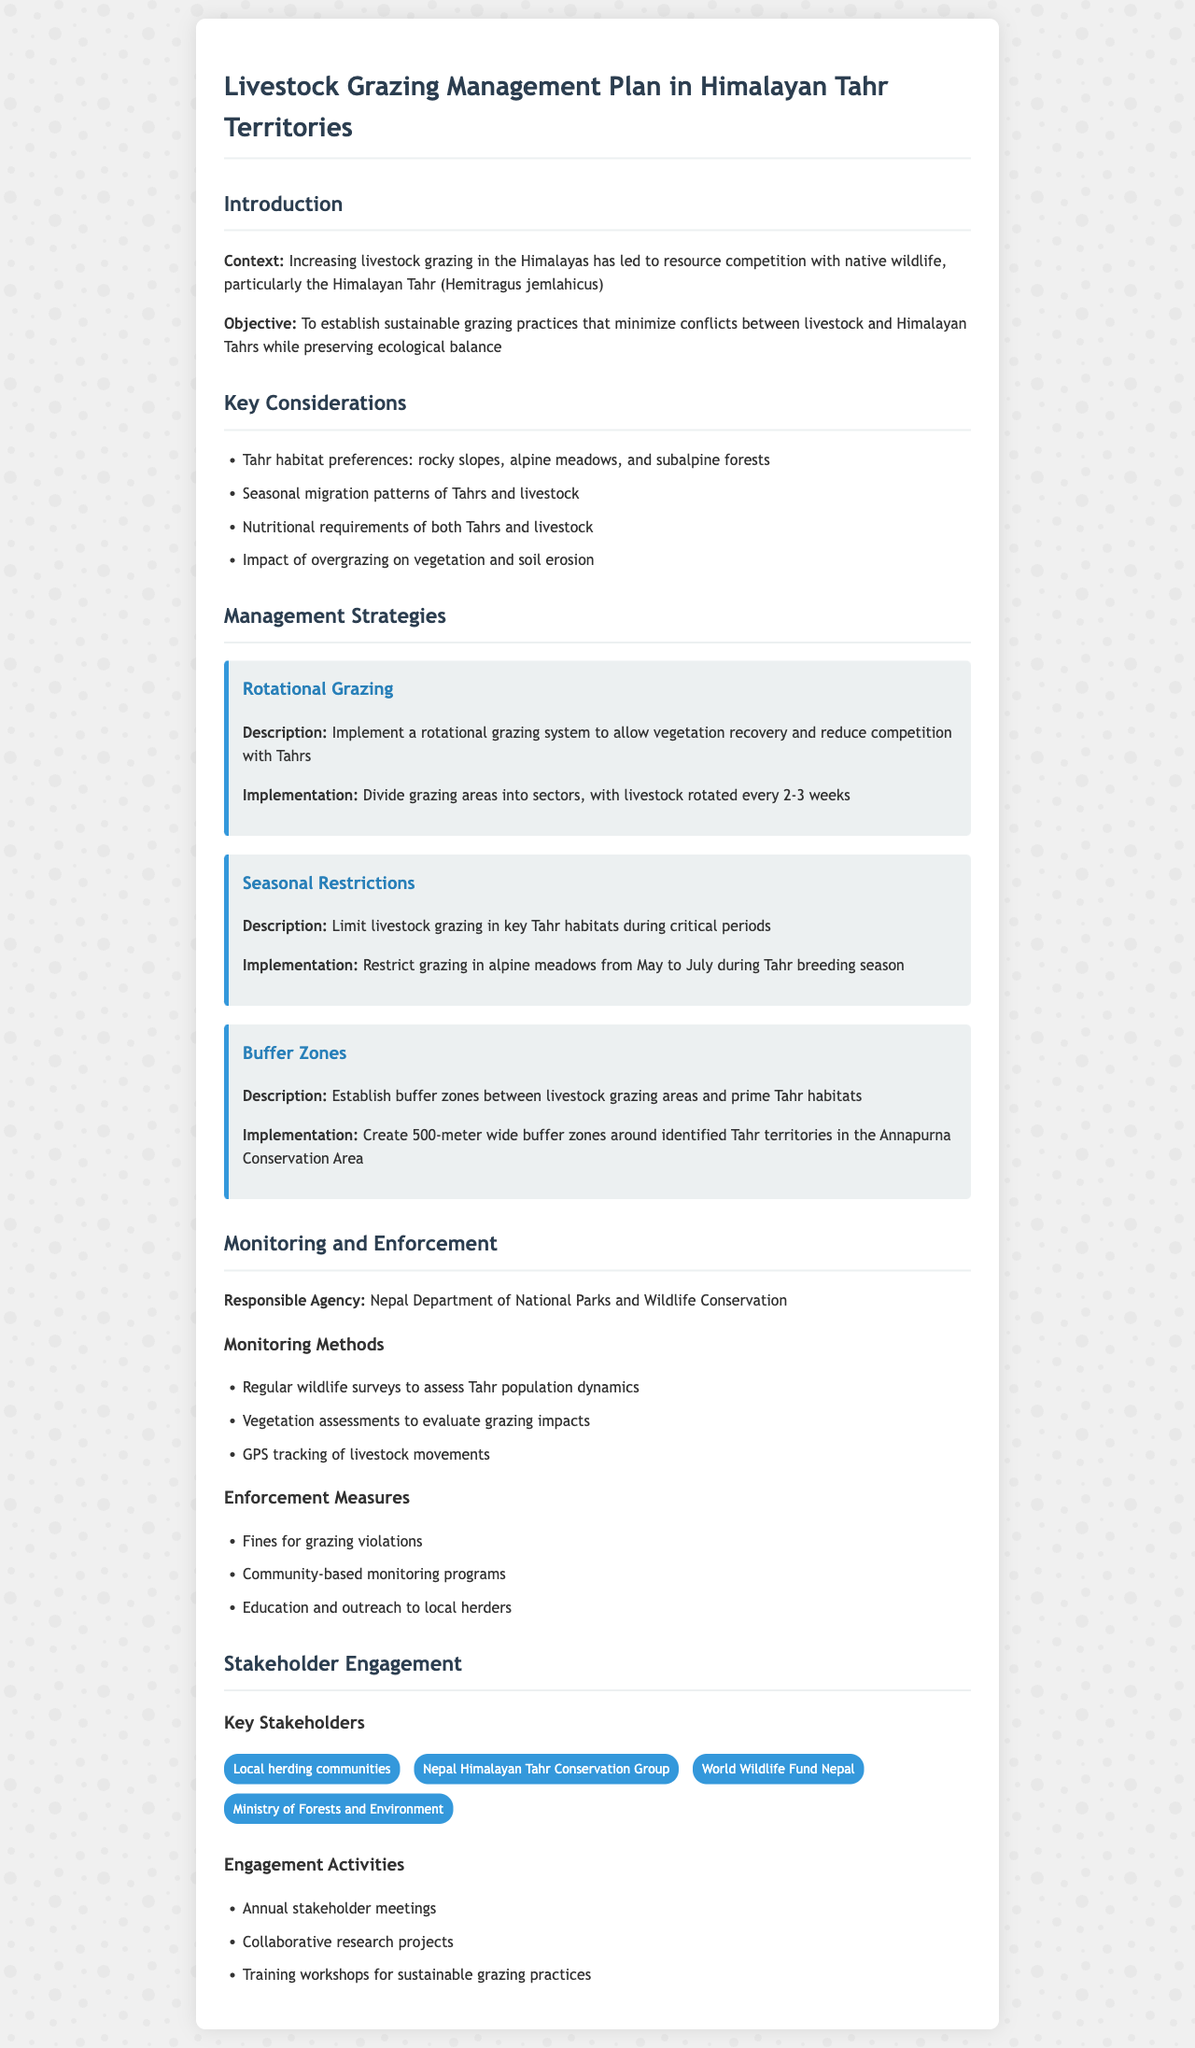What is the main objective of the grazing management plan? The objective is to establish sustainable grazing practices that minimize conflicts between livestock and Himalayan Tahrs while preserving ecological balance.
Answer: sustainable grazing practices What strategy involves dividing grazing areas into sectors? The strategy that implements a rotational grazing system requires the division of grazing areas into sectors for livestock rotation.
Answer: Rotational Grazing During which months are livestock grazing restrictions applied in key Tahr habitats? The grazing restrictions are applied from May to July during the critical Tahr breeding season.
Answer: May to July Which agency is responsible for monitoring the grazing management plan? The agency responsible for monitoring is the Nepal Department of National Parks and Wildlife Conservation.
Answer: Nepal Department of National Parks and Wildlife Conservation What is the width of the established buffer zones around Tahr territories? The buffer zones established around identified Tahr territories are 500 meters wide.
Answer: 500-meter What is one method used for monitoring livestock movements? GPS tracking is one method used to monitor livestock movements.
Answer: GPS tracking What type of communities are key stakeholders in this plan? Local herding communities are identified as key stakeholders in the grazing management plan.
Answer: Local herding communities How often are stakeholder meetings held? Stakeholder meetings are held annually.
Answer: Annual What does the strategy of seasonal restrictions aim to achieve? The strategy of seasonal restrictions aims to limit livestock grazing in habitats during critical periods for Tahrs.
Answer: limit livestock grazing 